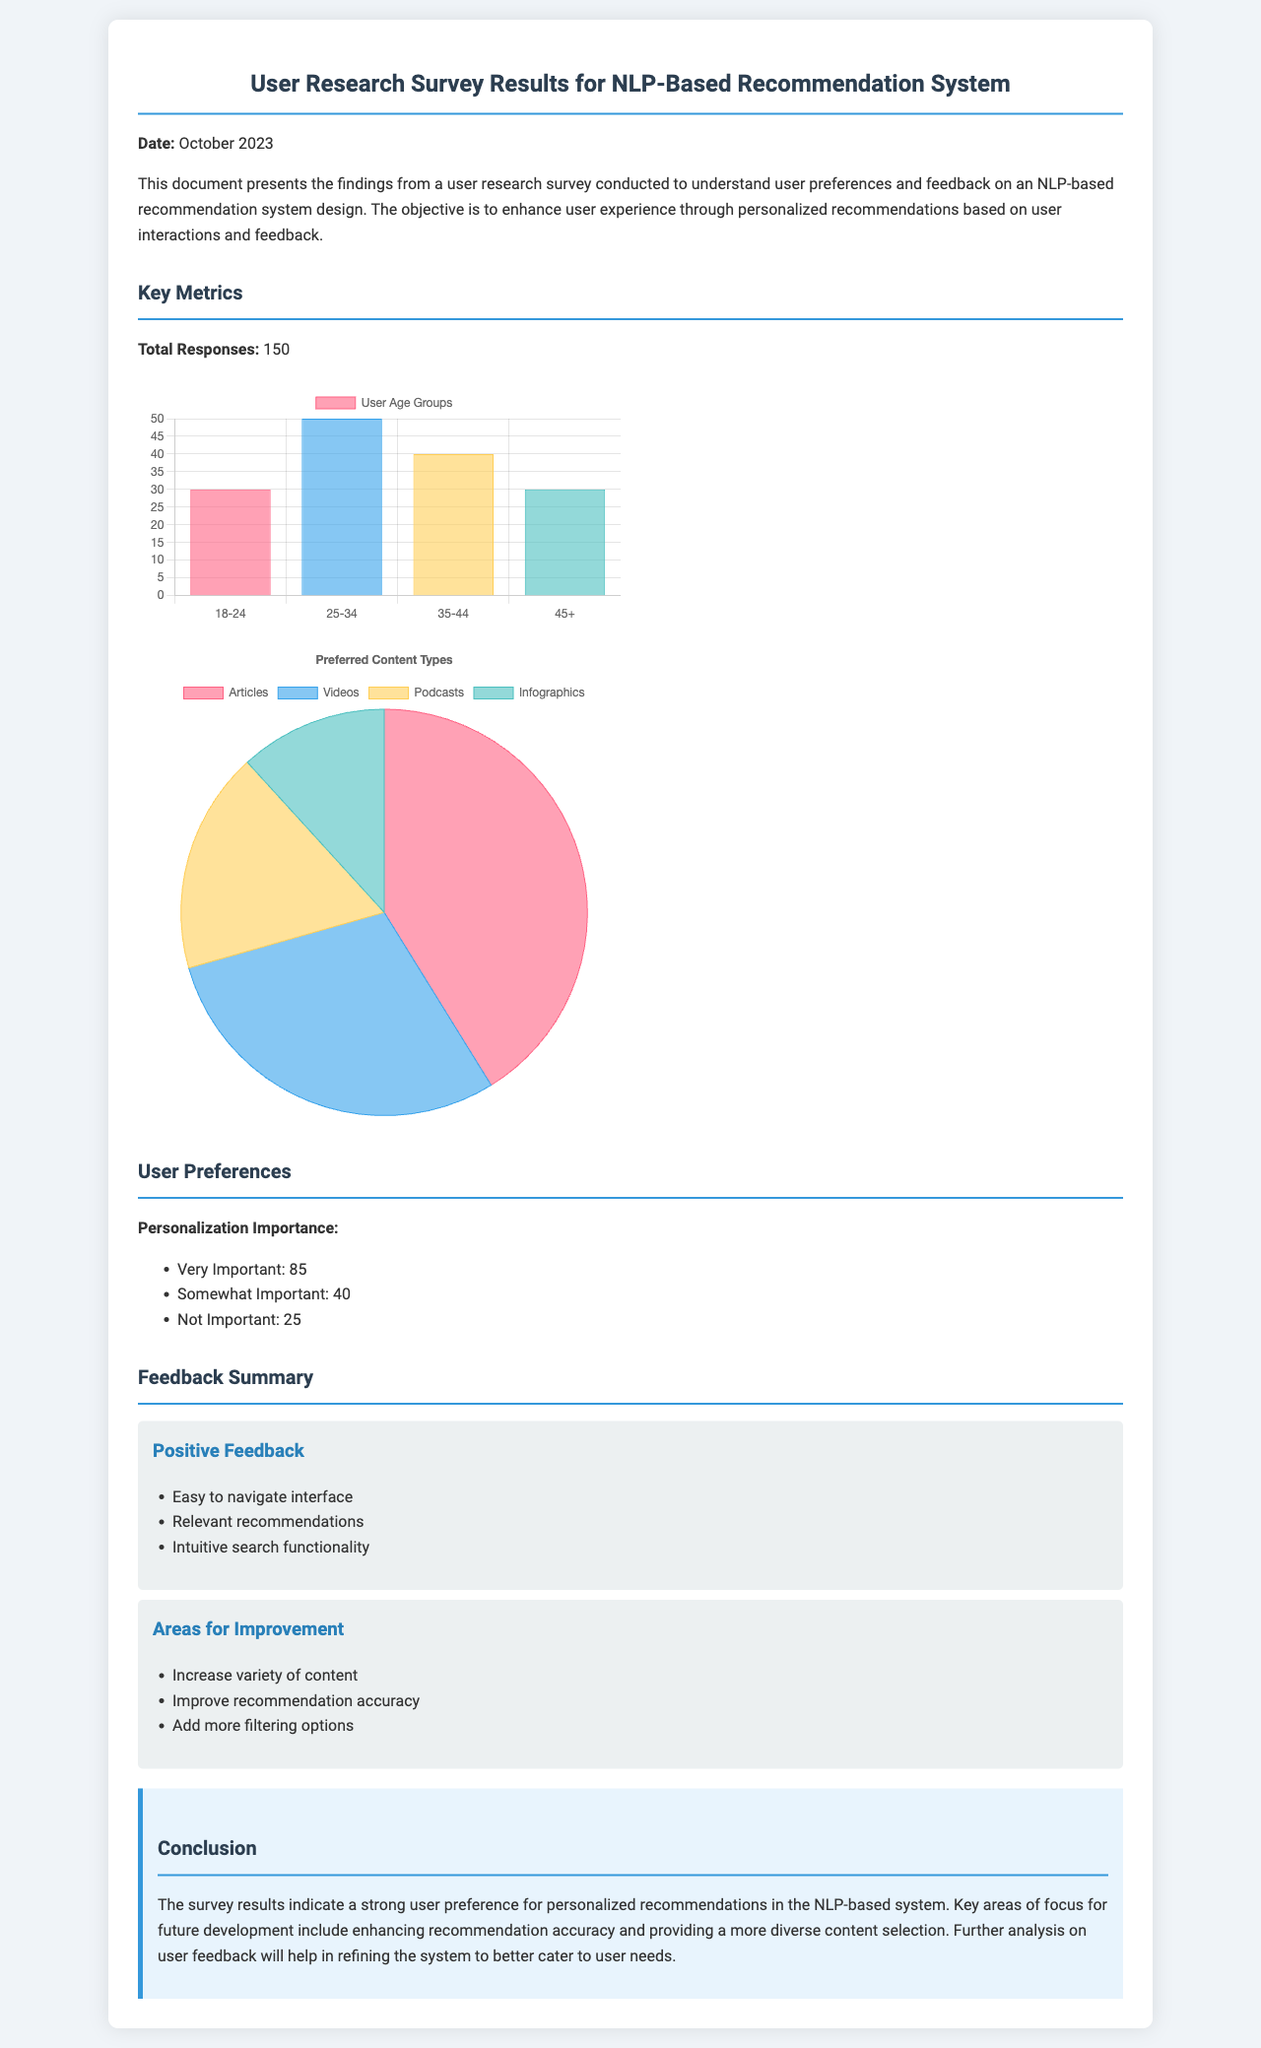What is the total number of survey responses? The total number of responses is specified as 150 in the document.
Answer: 150 What percentage of users found personalization very important? The survey results indicate that 85 users rated personalization as very important, which can be considered for percentage calculations.
Answer: 85 What is the highest age group represented in the survey? According to the age chart, the highest age group is 25-34 with 50 responses.
Answer: 25-34 Which content type received the least preference from users? The pie chart shows that infographics received the least preference with 20 responses.
Answer: Infographics What aspect of the recommendation system needs improvement according to user feedback? The document lists "Improve recommendation accuracy" as a key area for improvement based on user feedback.
Answer: Improve recommendation accuracy How many users found suggestions for more content variety important? The feedback indicates that "Increase variety of content" was mentioned as an area for improvement, implying significant user interest.
Answer: Increase variety of content What is the main conclusion regarding user preferences? The conclusion emphasizes a strong user preference for personalized recommendations in the NLP-based system.
Answer: Personalized recommendations What visual representation depicts preferred content types? The preferred content types are visualized in a pie chart within the document, demonstrating user preferences for different content types.
Answer: Pie chart Which feedback category lists easy navigation as a point of praise? Positive feedback includes the mention of "Easy to navigate interface," highlighting user appreciation.
Answer: Positive feedback 